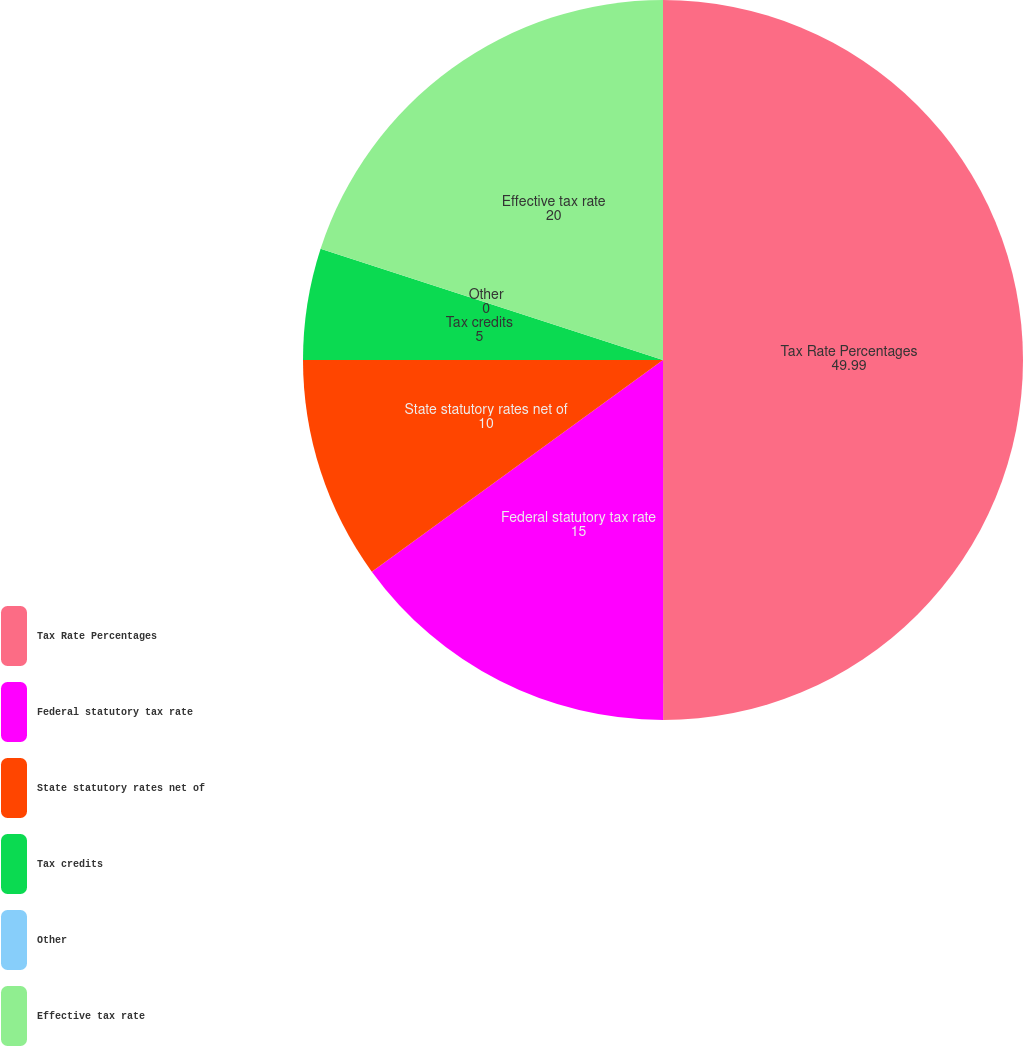Convert chart. <chart><loc_0><loc_0><loc_500><loc_500><pie_chart><fcel>Tax Rate Percentages<fcel>Federal statutory tax rate<fcel>State statutory rates net of<fcel>Tax credits<fcel>Other<fcel>Effective tax rate<nl><fcel>49.99%<fcel>15.0%<fcel>10.0%<fcel>5.0%<fcel>0.0%<fcel>20.0%<nl></chart> 